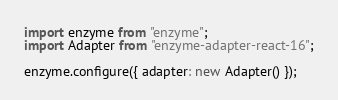Convert code to text. <code><loc_0><loc_0><loc_500><loc_500><_TypeScript_>import enzyme from "enzyme";
import Adapter from "enzyme-adapter-react-16";

enzyme.configure({ adapter: new Adapter() });
</code> 